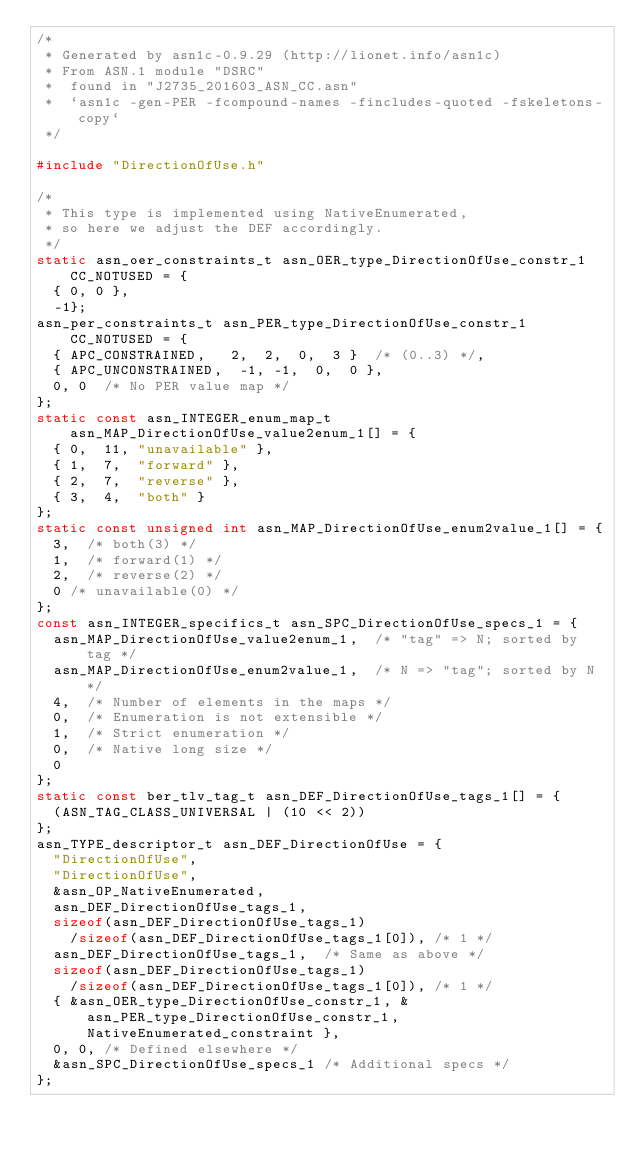<code> <loc_0><loc_0><loc_500><loc_500><_C_>/*
 * Generated by asn1c-0.9.29 (http://lionet.info/asn1c)
 * From ASN.1 module "DSRC"
 * 	found in "J2735_201603_ASN_CC.asn"
 * 	`asn1c -gen-PER -fcompound-names -fincludes-quoted -fskeletons-copy`
 */

#include "DirectionOfUse.h"

/*
 * This type is implemented using NativeEnumerated,
 * so here we adjust the DEF accordingly.
 */
static asn_oer_constraints_t asn_OER_type_DirectionOfUse_constr_1 CC_NOTUSED = {
	{ 0, 0 },
	-1};
asn_per_constraints_t asn_PER_type_DirectionOfUse_constr_1 CC_NOTUSED = {
	{ APC_CONSTRAINED,	 2,  2,  0,  3 }	/* (0..3) */,
	{ APC_UNCONSTRAINED,	-1, -1,  0,  0 },
	0, 0	/* No PER value map */
};
static const asn_INTEGER_enum_map_t asn_MAP_DirectionOfUse_value2enum_1[] = {
	{ 0,	11,	"unavailable" },
	{ 1,	7,	"forward" },
	{ 2,	7,	"reverse" },
	{ 3,	4,	"both" }
};
static const unsigned int asn_MAP_DirectionOfUse_enum2value_1[] = {
	3,	/* both(3) */
	1,	/* forward(1) */
	2,	/* reverse(2) */
	0	/* unavailable(0) */
};
const asn_INTEGER_specifics_t asn_SPC_DirectionOfUse_specs_1 = {
	asn_MAP_DirectionOfUse_value2enum_1,	/* "tag" => N; sorted by tag */
	asn_MAP_DirectionOfUse_enum2value_1,	/* N => "tag"; sorted by N */
	4,	/* Number of elements in the maps */
	0,	/* Enumeration is not extensible */
	1,	/* Strict enumeration */
	0,	/* Native long size */
	0
};
static const ber_tlv_tag_t asn_DEF_DirectionOfUse_tags_1[] = {
	(ASN_TAG_CLASS_UNIVERSAL | (10 << 2))
};
asn_TYPE_descriptor_t asn_DEF_DirectionOfUse = {
	"DirectionOfUse",
	"DirectionOfUse",
	&asn_OP_NativeEnumerated,
	asn_DEF_DirectionOfUse_tags_1,
	sizeof(asn_DEF_DirectionOfUse_tags_1)
		/sizeof(asn_DEF_DirectionOfUse_tags_1[0]), /* 1 */
	asn_DEF_DirectionOfUse_tags_1,	/* Same as above */
	sizeof(asn_DEF_DirectionOfUse_tags_1)
		/sizeof(asn_DEF_DirectionOfUse_tags_1[0]), /* 1 */
	{ &asn_OER_type_DirectionOfUse_constr_1, &asn_PER_type_DirectionOfUse_constr_1, NativeEnumerated_constraint },
	0, 0,	/* Defined elsewhere */
	&asn_SPC_DirectionOfUse_specs_1	/* Additional specs */
};

</code> 